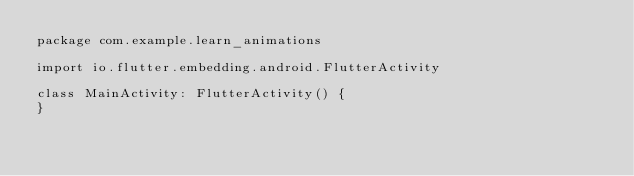Convert code to text. <code><loc_0><loc_0><loc_500><loc_500><_Kotlin_>package com.example.learn_animations

import io.flutter.embedding.android.FlutterActivity

class MainActivity: FlutterActivity() {
}
</code> 